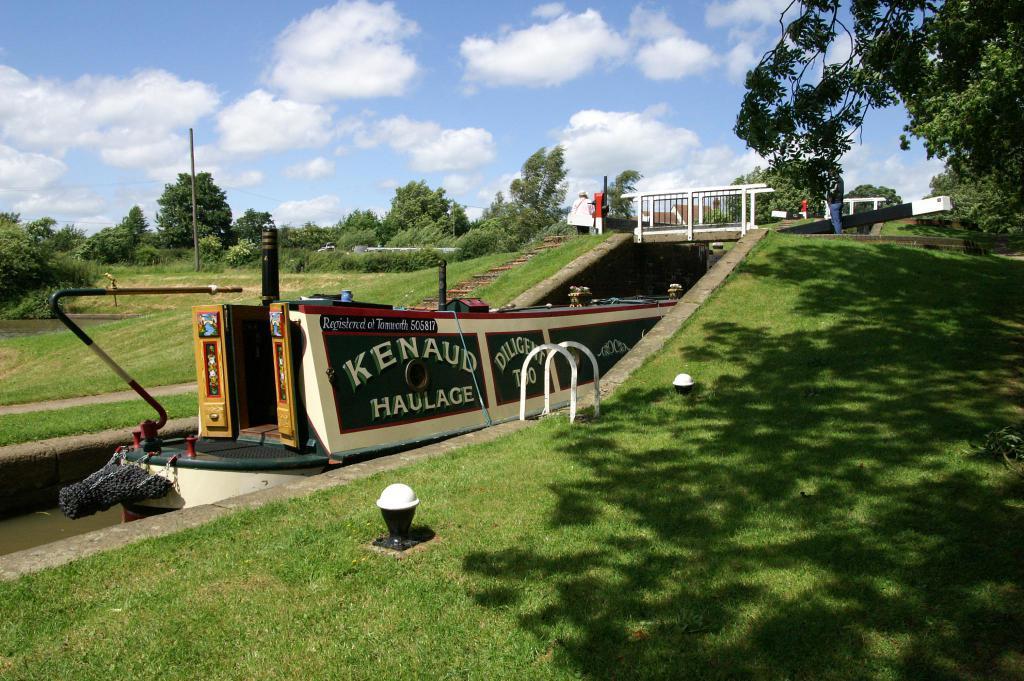Please provide a concise description of this image. In this image we can see grass on the ground. Also there are small light bulbs on the ground. Also there is boat on the water. On the boat we can see text. And there is a bridge with railings. And we can see two persons. In the back there are trees. Also there is sky with clouds. 